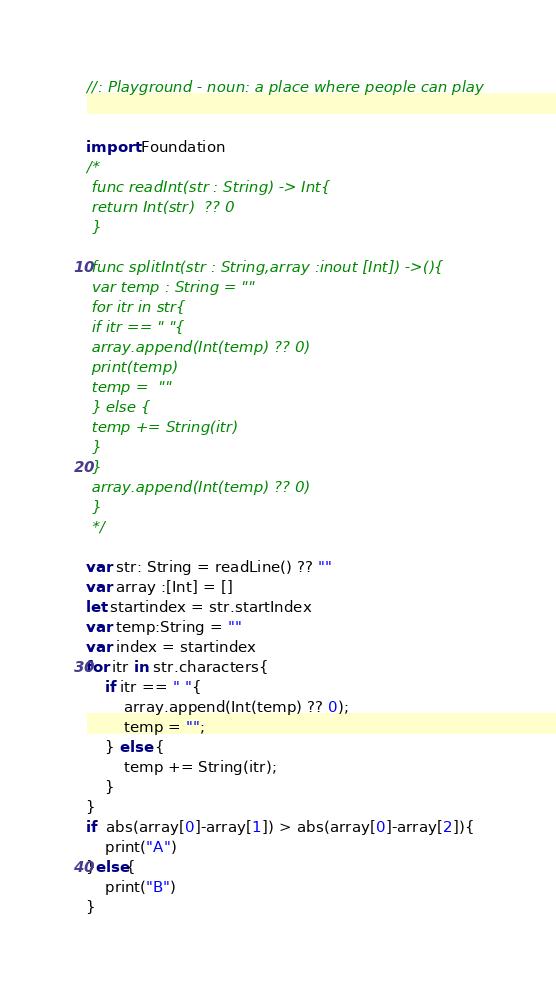Convert code to text. <code><loc_0><loc_0><loc_500><loc_500><_Swift_>//: Playground - noun: a place where people can play


import Foundation
/*
 func readInt(str : String) -> Int{
 return Int(str)  ?? 0
 }
 
 func splitInt(str : String,array :inout [Int]) ->(){
 var temp : String = ""
 for itr in str{
 if itr == " "{
 array.append(Int(temp) ?? 0)
 print(temp)
 temp =  ""
 } else {
 temp += String(itr)
 }
 }
 array.append(Int(temp) ?? 0)
 }
 */

var str: String = readLine() ?? ""
var array :[Int] = []
let startindex = str.startIndex
var temp:String = ""
var index = startindex
for itr in str.characters{
    if itr == " "{
        array.append(Int(temp) ?? 0);
        temp = "";
    } else {
        temp += String(itr);
    }
}
if  abs(array[0]-array[1]) > abs(array[0]-array[2]){
    print("A")
}else{
    print("B")
}

</code> 